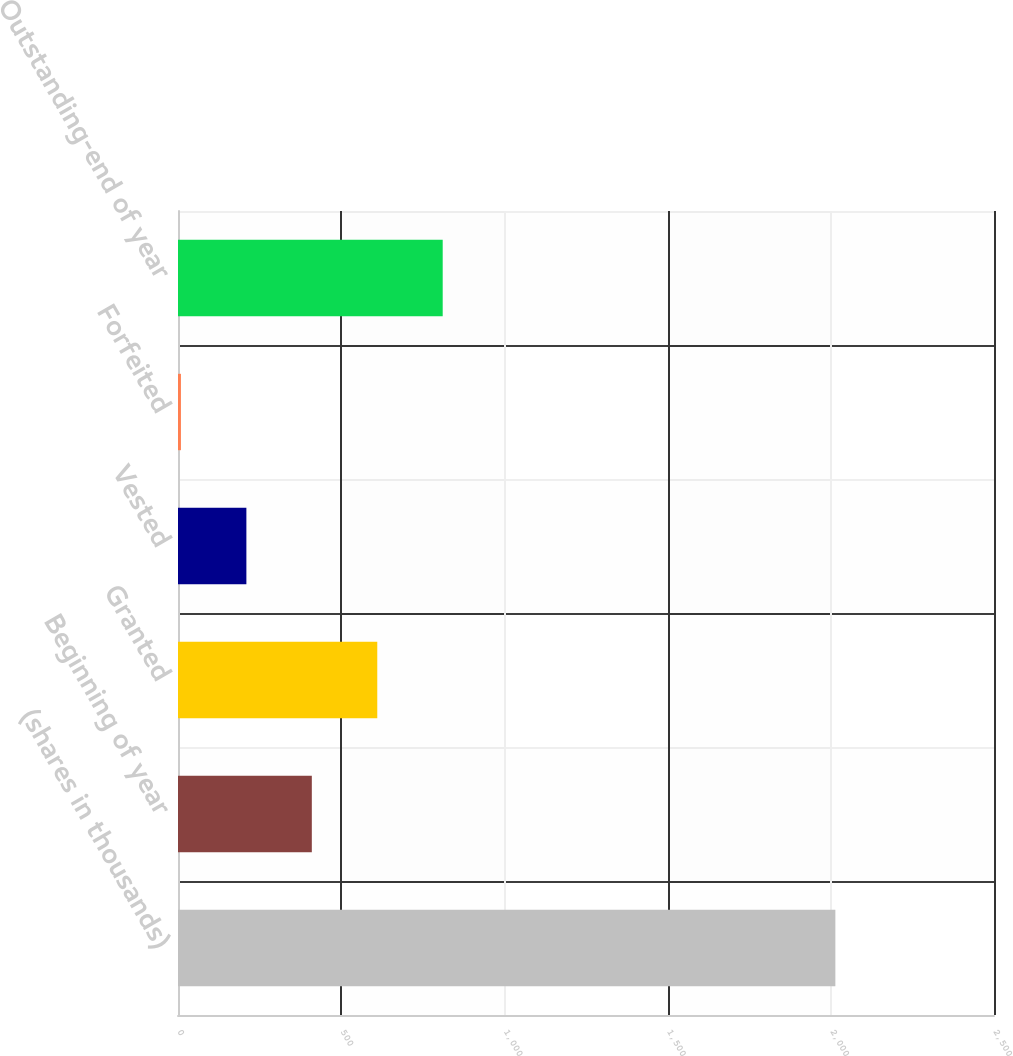Convert chart to OTSL. <chart><loc_0><loc_0><loc_500><loc_500><bar_chart><fcel>(shares in thousands)<fcel>Beginning of year<fcel>Granted<fcel>Vested<fcel>Forfeited<fcel>Outstanding-end of year<nl><fcel>2014<fcel>410<fcel>610.5<fcel>209.5<fcel>9<fcel>811<nl></chart> 